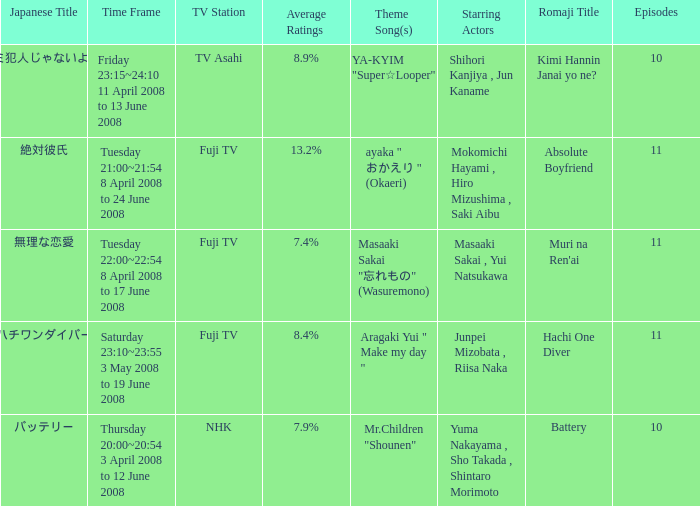What are the japanese title(s) for tv asahi? キミ犯人じゃないよね?. 